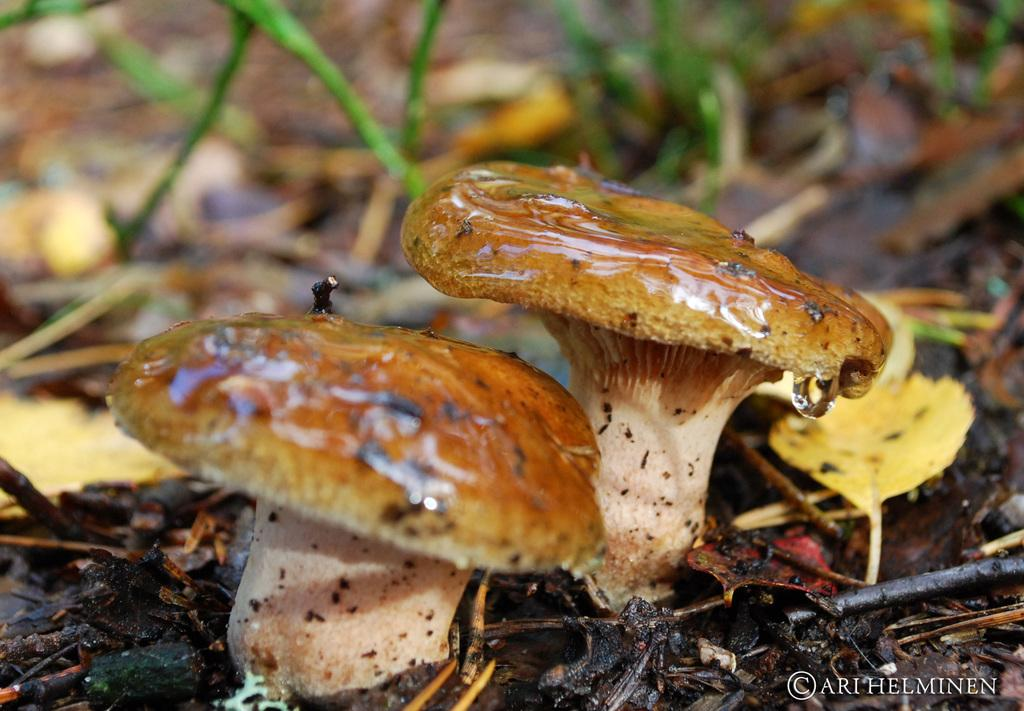What type of fungi can be seen in the image? There are mushrooms in the image. Where are the mushrooms located? The mushrooms are on the ground. What type of lace can be seen on the mushrooms in the image? There is no lace present on the mushrooms in the image. 